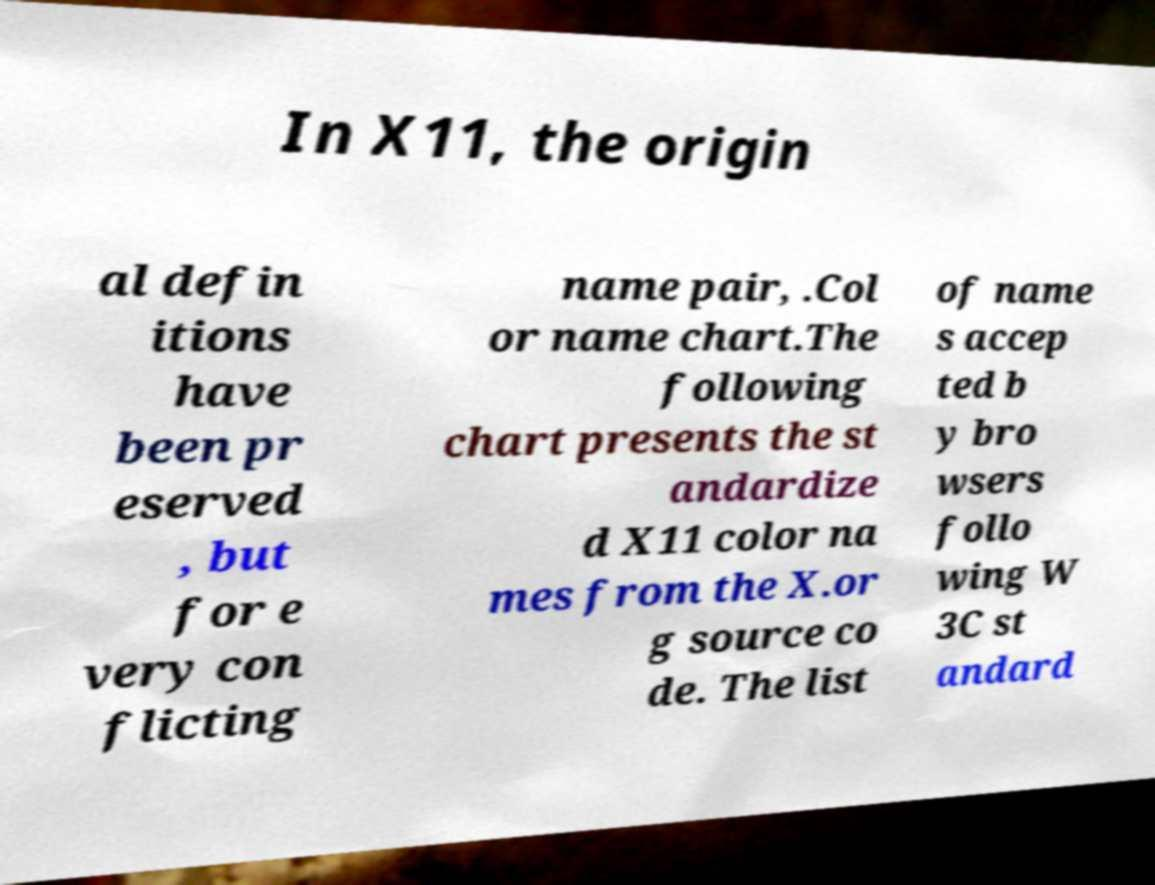Can you accurately transcribe the text from the provided image for me? In X11, the origin al defin itions have been pr eserved , but for e very con flicting name pair, .Col or name chart.The following chart presents the st andardize d X11 color na mes from the X.or g source co de. The list of name s accep ted b y bro wsers follo wing W 3C st andard 